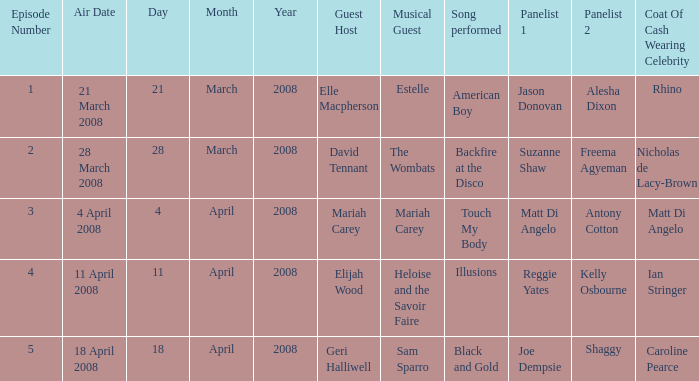Name the number of panelists for oat of cash wearing celebrity being matt di angelo 1.0. 